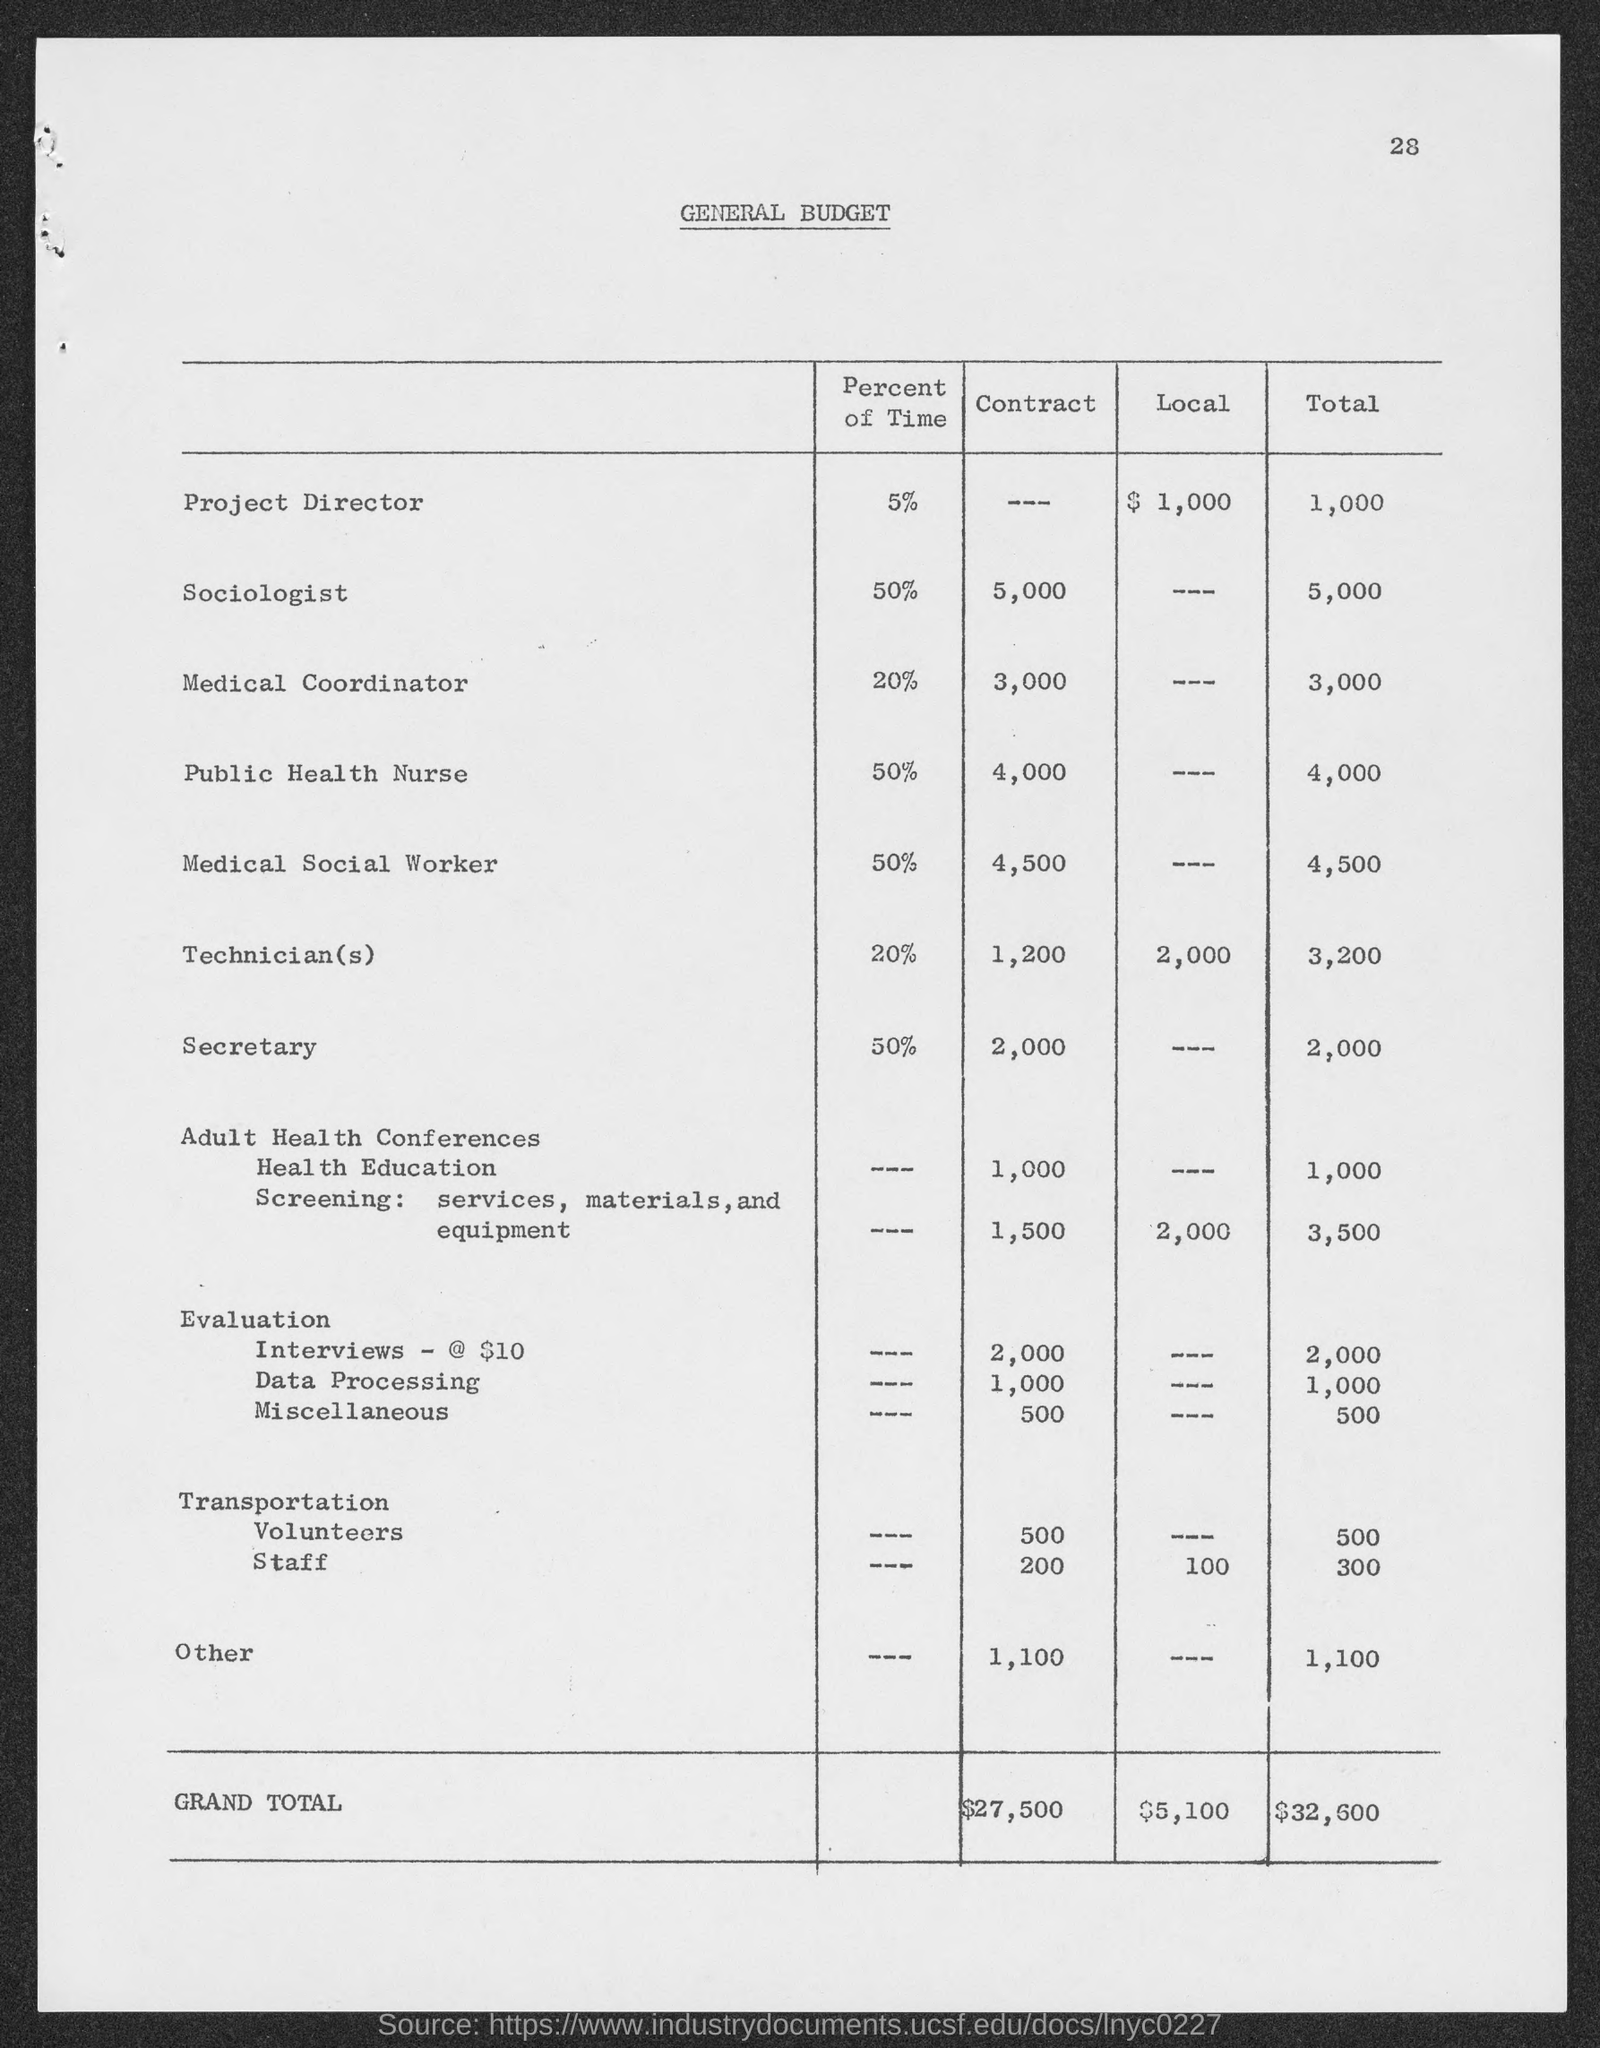Can you tell me what the total budget is for Public Health Nurse? The total budget for the Public Health Nurse is $4,000, as indicated in the 'Total' column, which is solely from the 'Contract' source without local funding. 